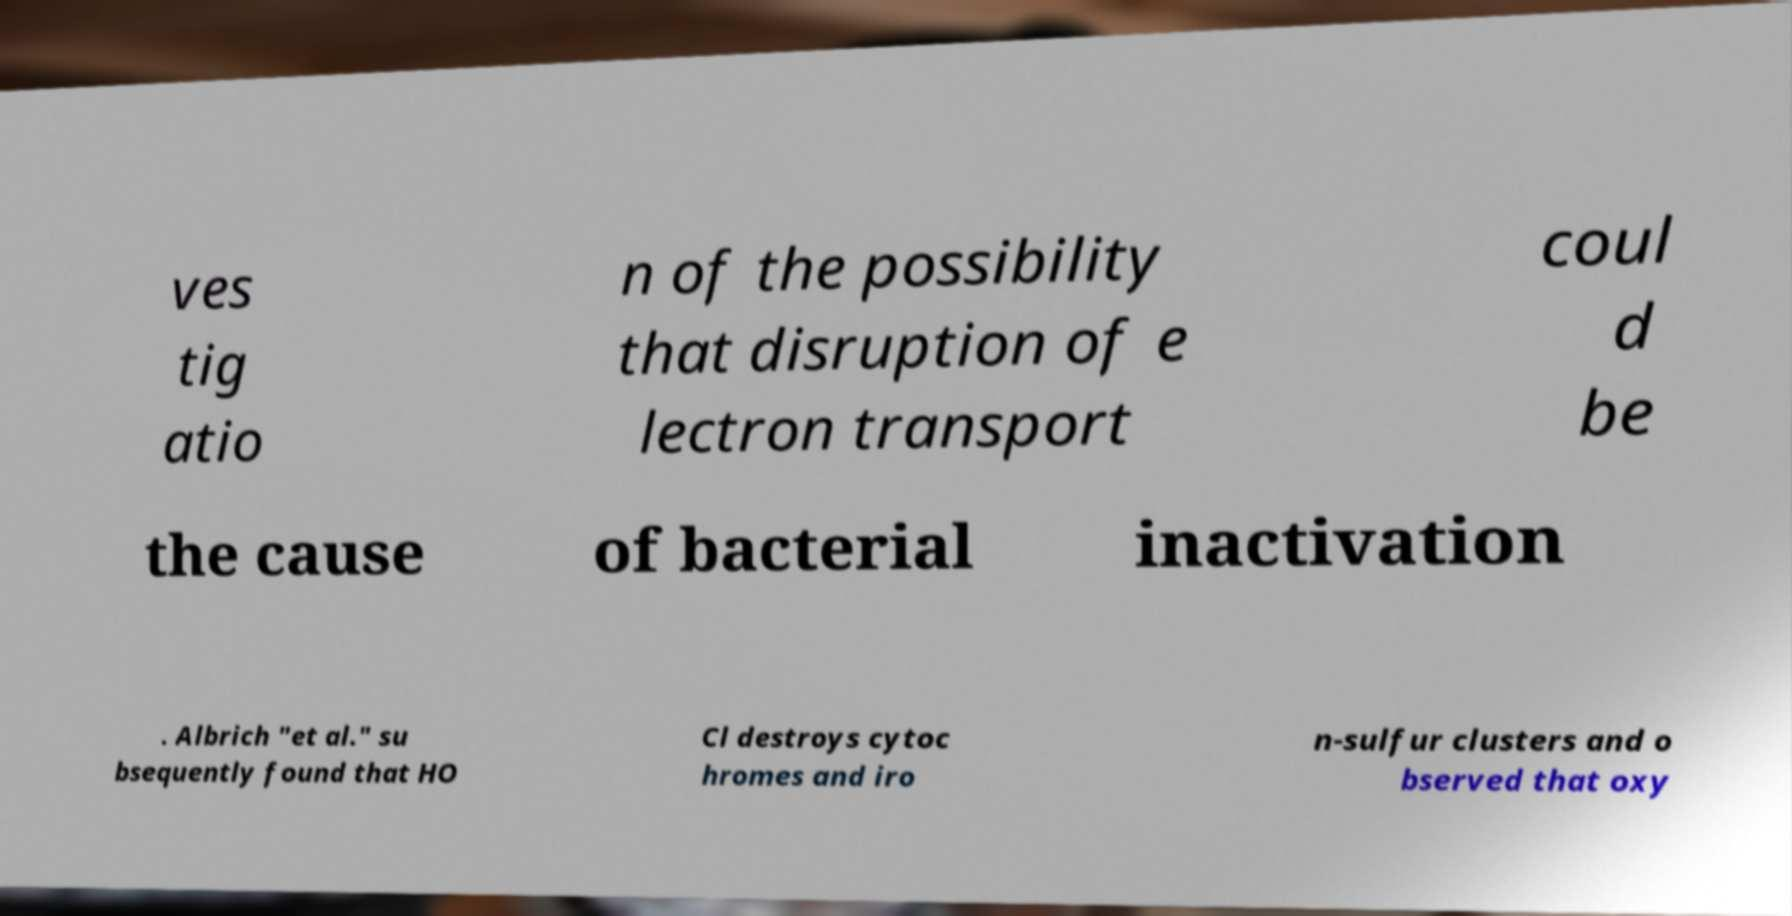Can you accurately transcribe the text from the provided image for me? ves tig atio n of the possibility that disruption of e lectron transport coul d be the cause of bacterial inactivation . Albrich "et al." su bsequently found that HO Cl destroys cytoc hromes and iro n-sulfur clusters and o bserved that oxy 